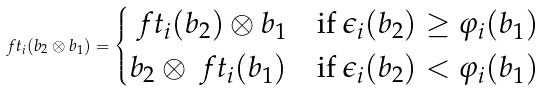Convert formula to latex. <formula><loc_0><loc_0><loc_500><loc_500>\ f t _ { i } ( b _ { 2 } \otimes b _ { 1 } ) = \begin{cases} \ f t _ { i } ( b _ { 2 } ) \otimes b _ { 1 } & \text {if $\epsilon_{i}(b_{2})\geq \varphi_{i}(b_{1})$} \\ b _ { 2 } \otimes \ f t _ { i } ( b _ { 1 } ) & \text {if $\epsilon_{i}(b_{2})<\varphi_{i}(b_{1})$} \end{cases}</formula> 